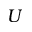Convert formula to latex. <formula><loc_0><loc_0><loc_500><loc_500>U</formula> 